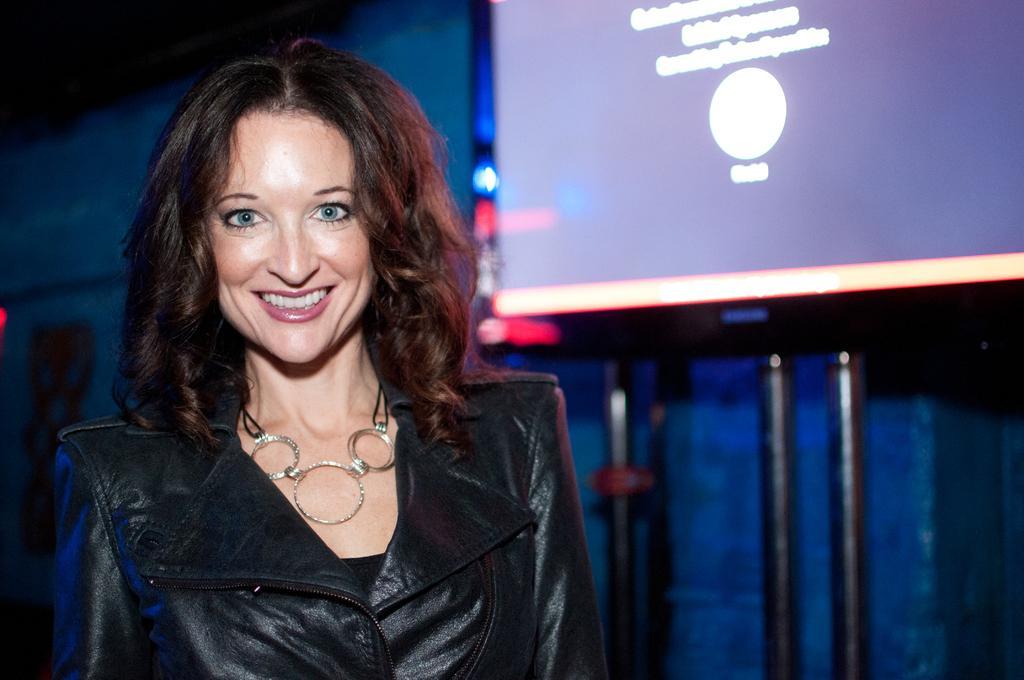Please provide a concise description of this image. In the picture we can see a woman wearing a black dress and standing and she is smiling and in the background, we can see a wall with a screen and some poles under it. 